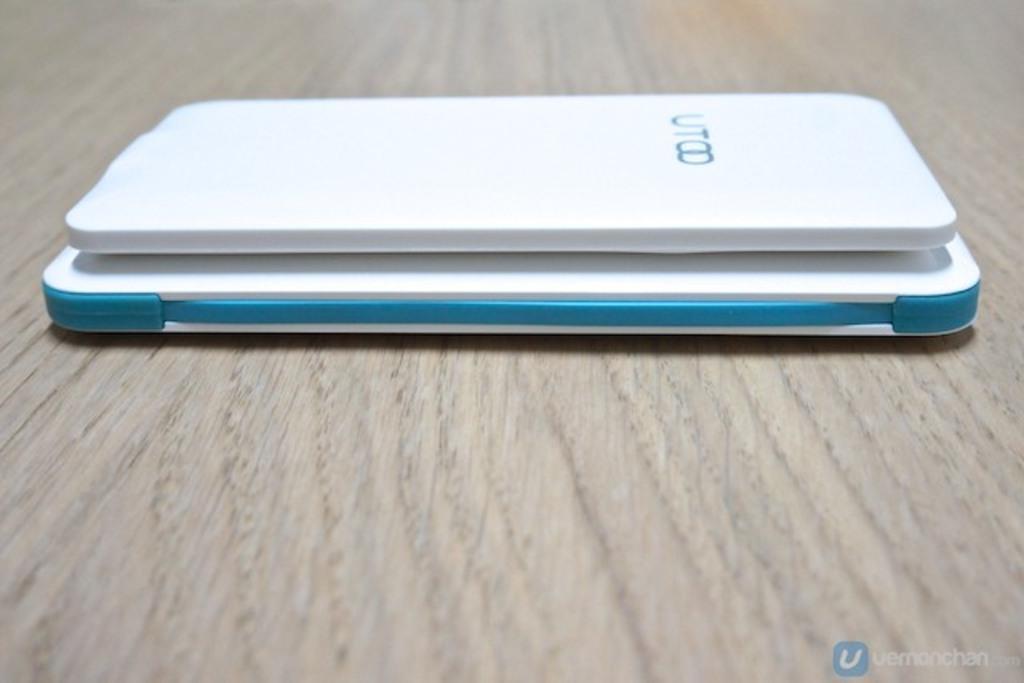Describe this image in one or two sentences. These are the two electronic gadgets in white color. 